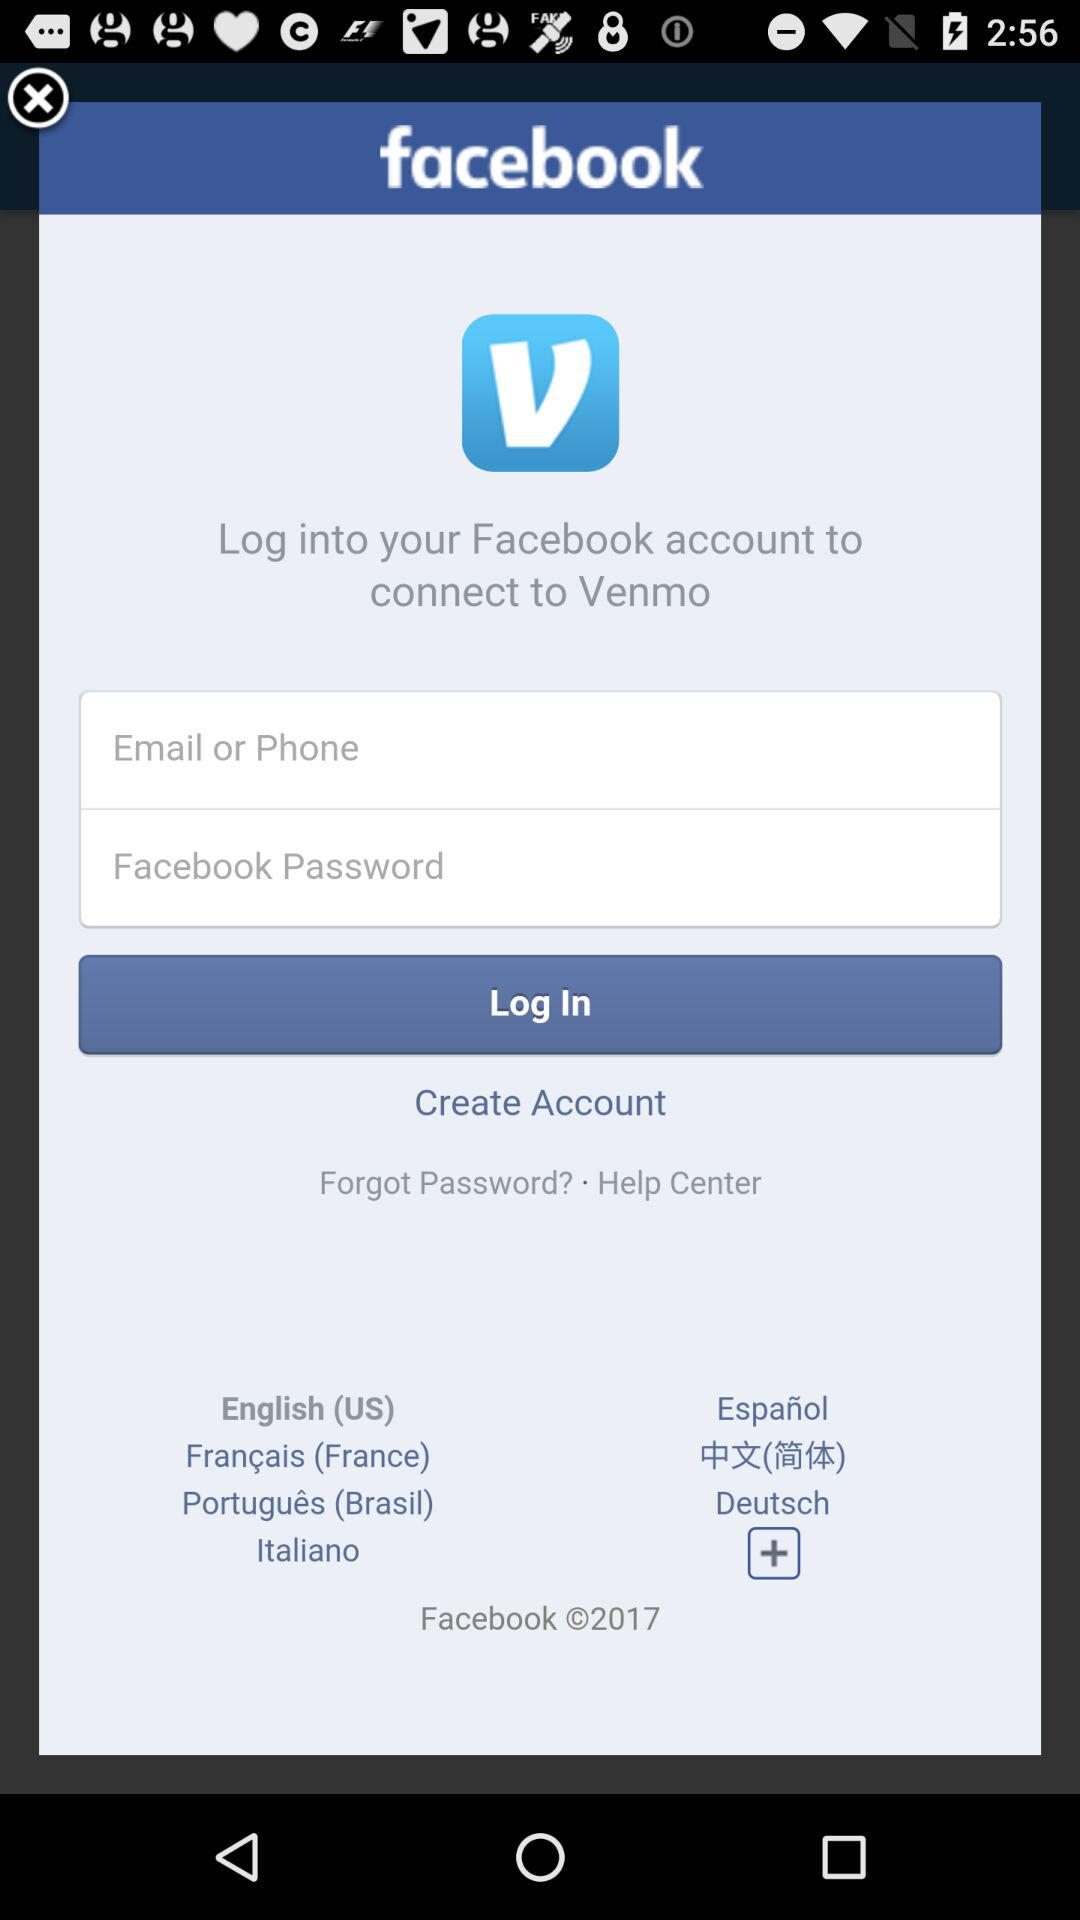Log into your Facebook account to connect to which app? Log into your Facebook account to connect to the Venmo app. 